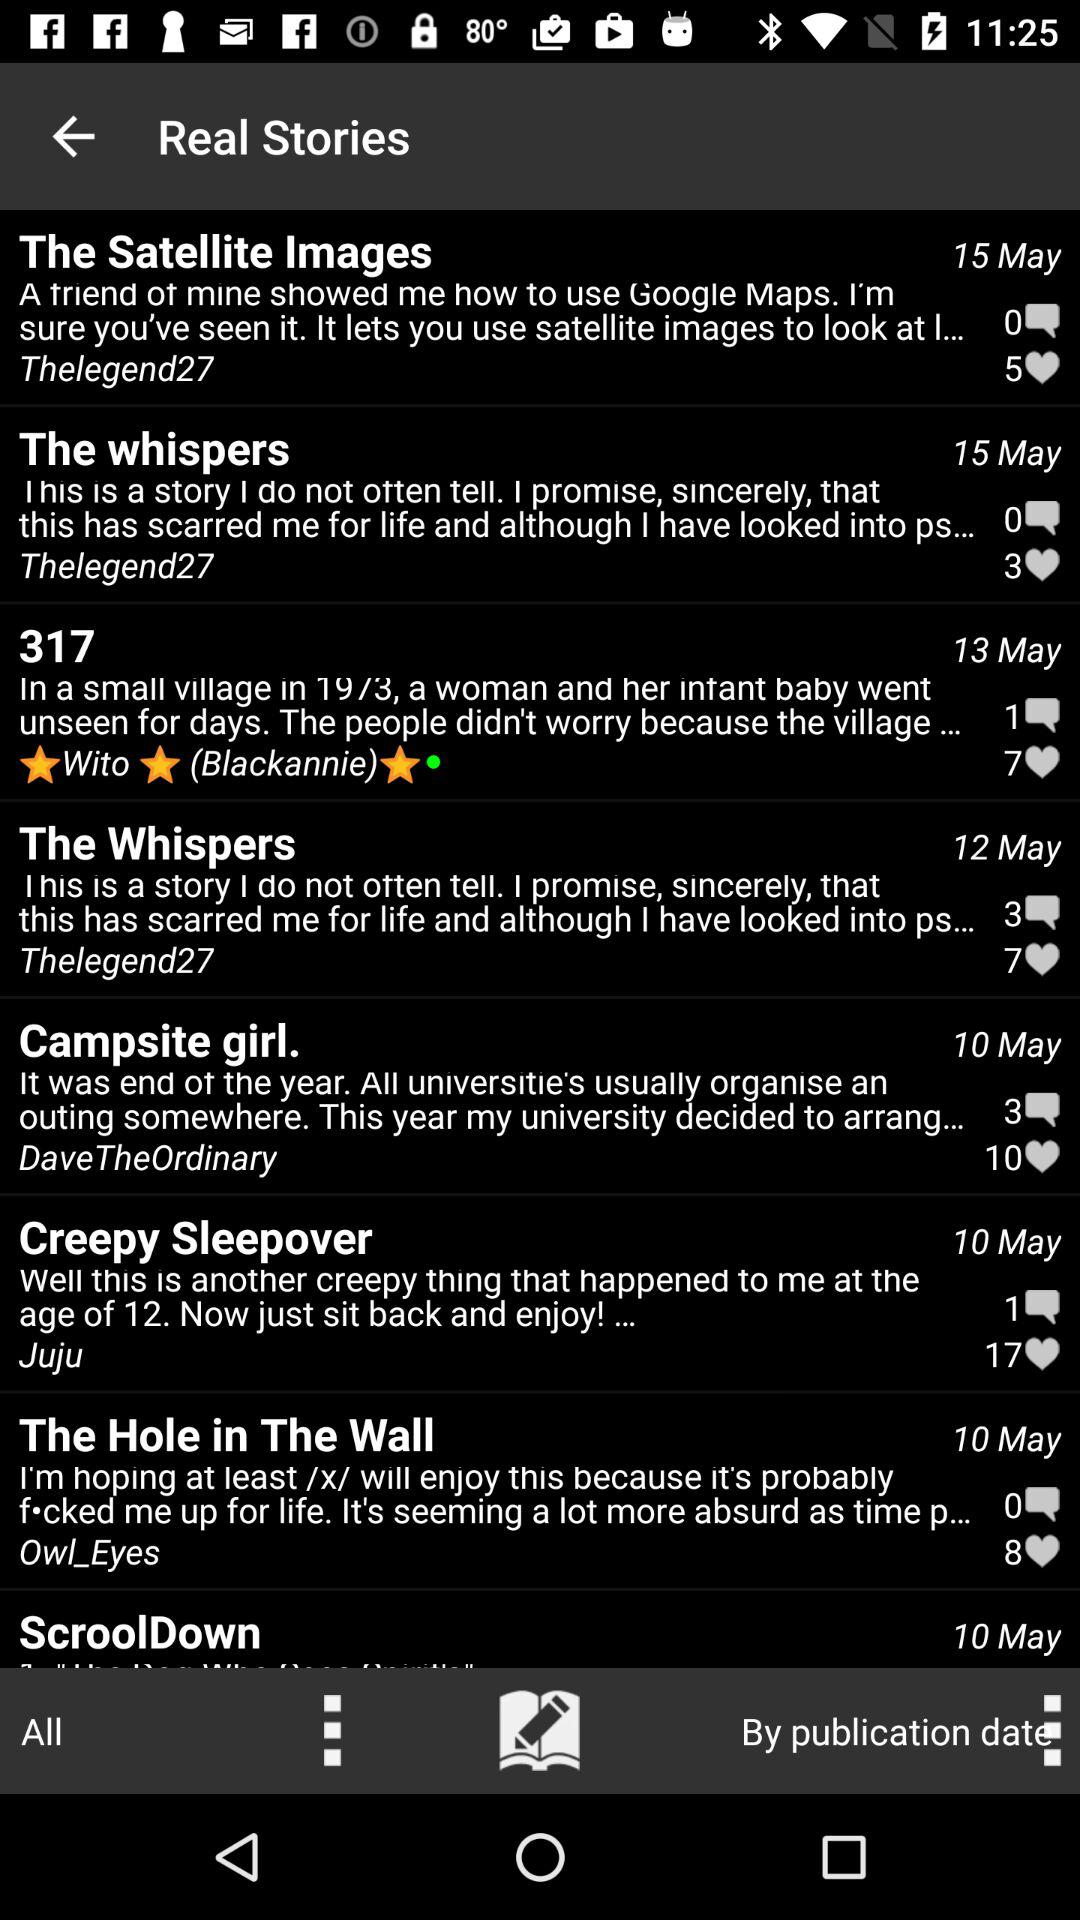How many comments are there in the satellite images? There are 0 comments. 